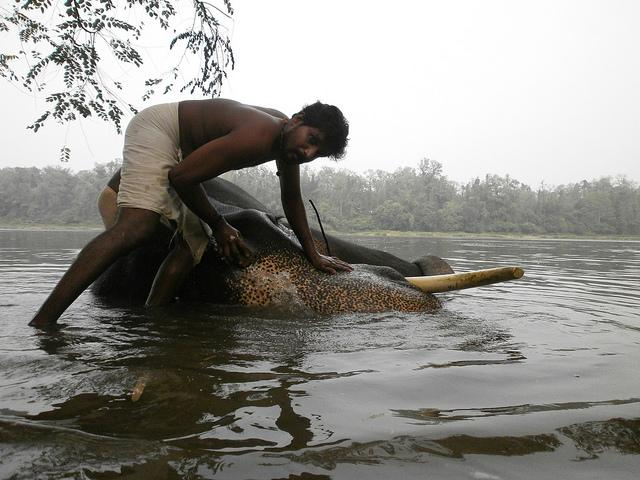What is the yellowish hard item sticking out from the animal? Please explain your reasoning. tusk. The animal has a white hard item sticking out of its body, and the term in a matches the description. 